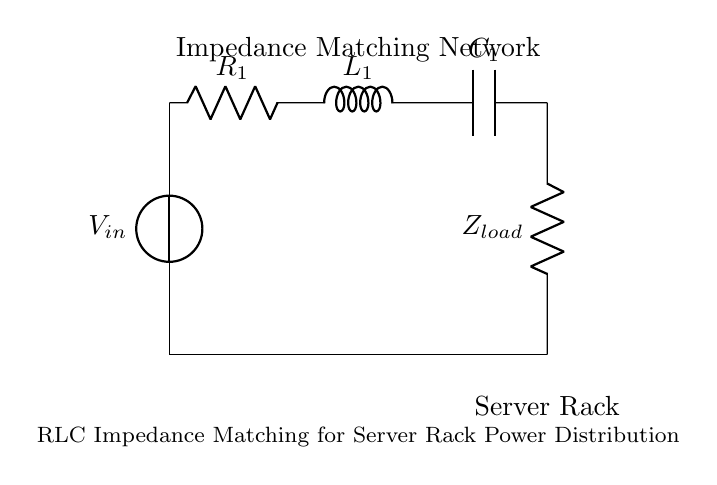What is the type of load in this circuit? The load is represented by Z load, which is a resistor that signifies the server rack load in the impedance matching network.
Answer: Z load What are the components in the impedance matching network? The components consist of a resistor R one, an inductor L one, and a capacitor C one. These components work together to optimize impedance.
Answer: R one, L one, C one What is the purpose of the impedance matching network? The impedance matching network is designed to minimize reflections and maximize power transfer from the source to the load, enhancing the overall efficiency of power distribution.
Answer: Minimize reflections What is the total number of passive components used in this circuit? There are three passive components used: one resistor, one inductor, and one capacitor, which collectively form the impedance matching network.
Answer: Three If all components are ideally tuned, what will be the effect on power distribution? When components are ideally tuned, the power distribution is optimized, and maximum power transfer occurs, leading to enhanced performance in the server rack.
Answer: Optimized power distribution Which component in the network primarily influences reactive power? The inductor L one primarily influences reactive power in the network, as it stores energy in a magnetic field, affecting the circuit's phase relationship.
Answer: L one How would a mismatch in Z load affect the circuit performance? A mismatch in Z load would lead to reduced power transfer efficiency, increased reflections, and potential overheating of components due to improper load conditions.
Answer: Reduced efficiency 